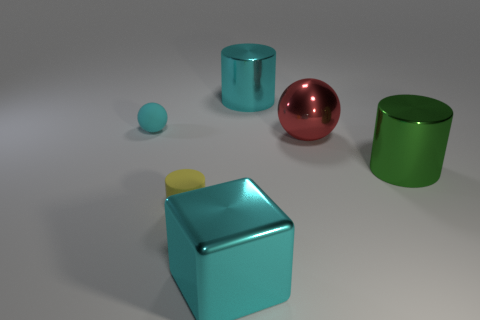Add 3 blue rubber balls. How many objects exist? 9 Subtract all large cyan cylinders. How many cylinders are left? 2 Subtract all balls. How many objects are left? 4 Subtract 2 cylinders. How many cylinders are left? 1 Subtract all red spheres. How many spheres are left? 1 Subtract 0 yellow blocks. How many objects are left? 6 Subtract all purple cubes. Subtract all green balls. How many cubes are left? 1 Subtract all big green metallic cylinders. Subtract all large metallic spheres. How many objects are left? 4 Add 1 tiny cyan balls. How many tiny cyan balls are left? 2 Add 2 big metal objects. How many big metal objects exist? 6 